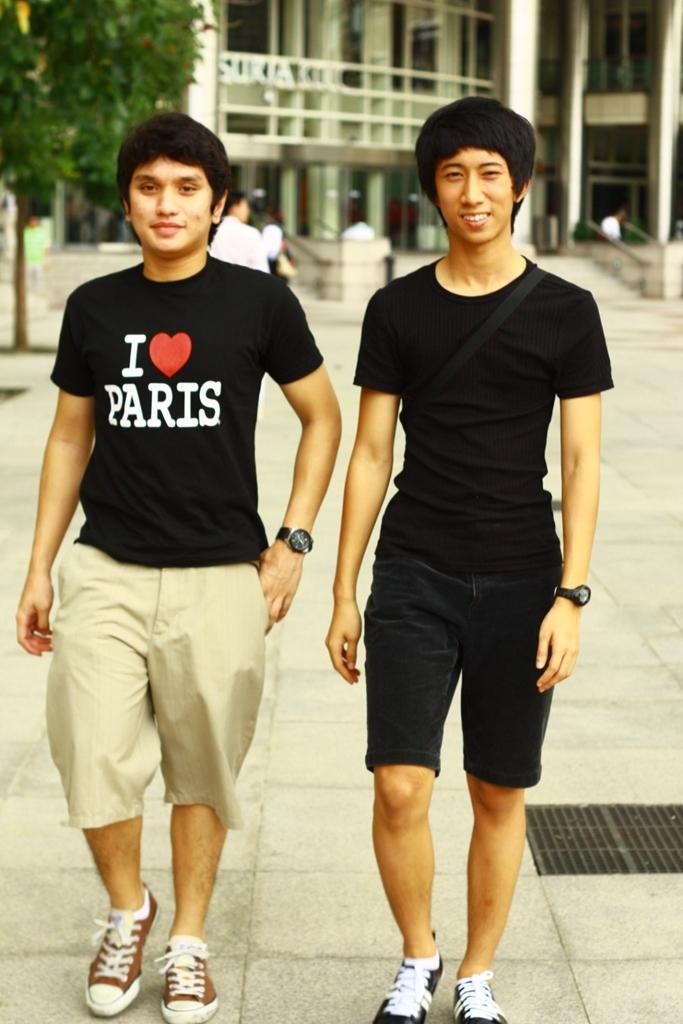How many people are in the image? There are two persons standing in the image. What are the people wearing? The persons are wearing clothes. What can be seen in the top left corner of the image? There is a tree in the top left of the image. What structure is visible at the top of the image? There is a building at the top of the image. Can you tell me how many grains of sand are on the ground in the image? There is no sand visible in the image, so it is not possible to determine the number of grains of sand. 